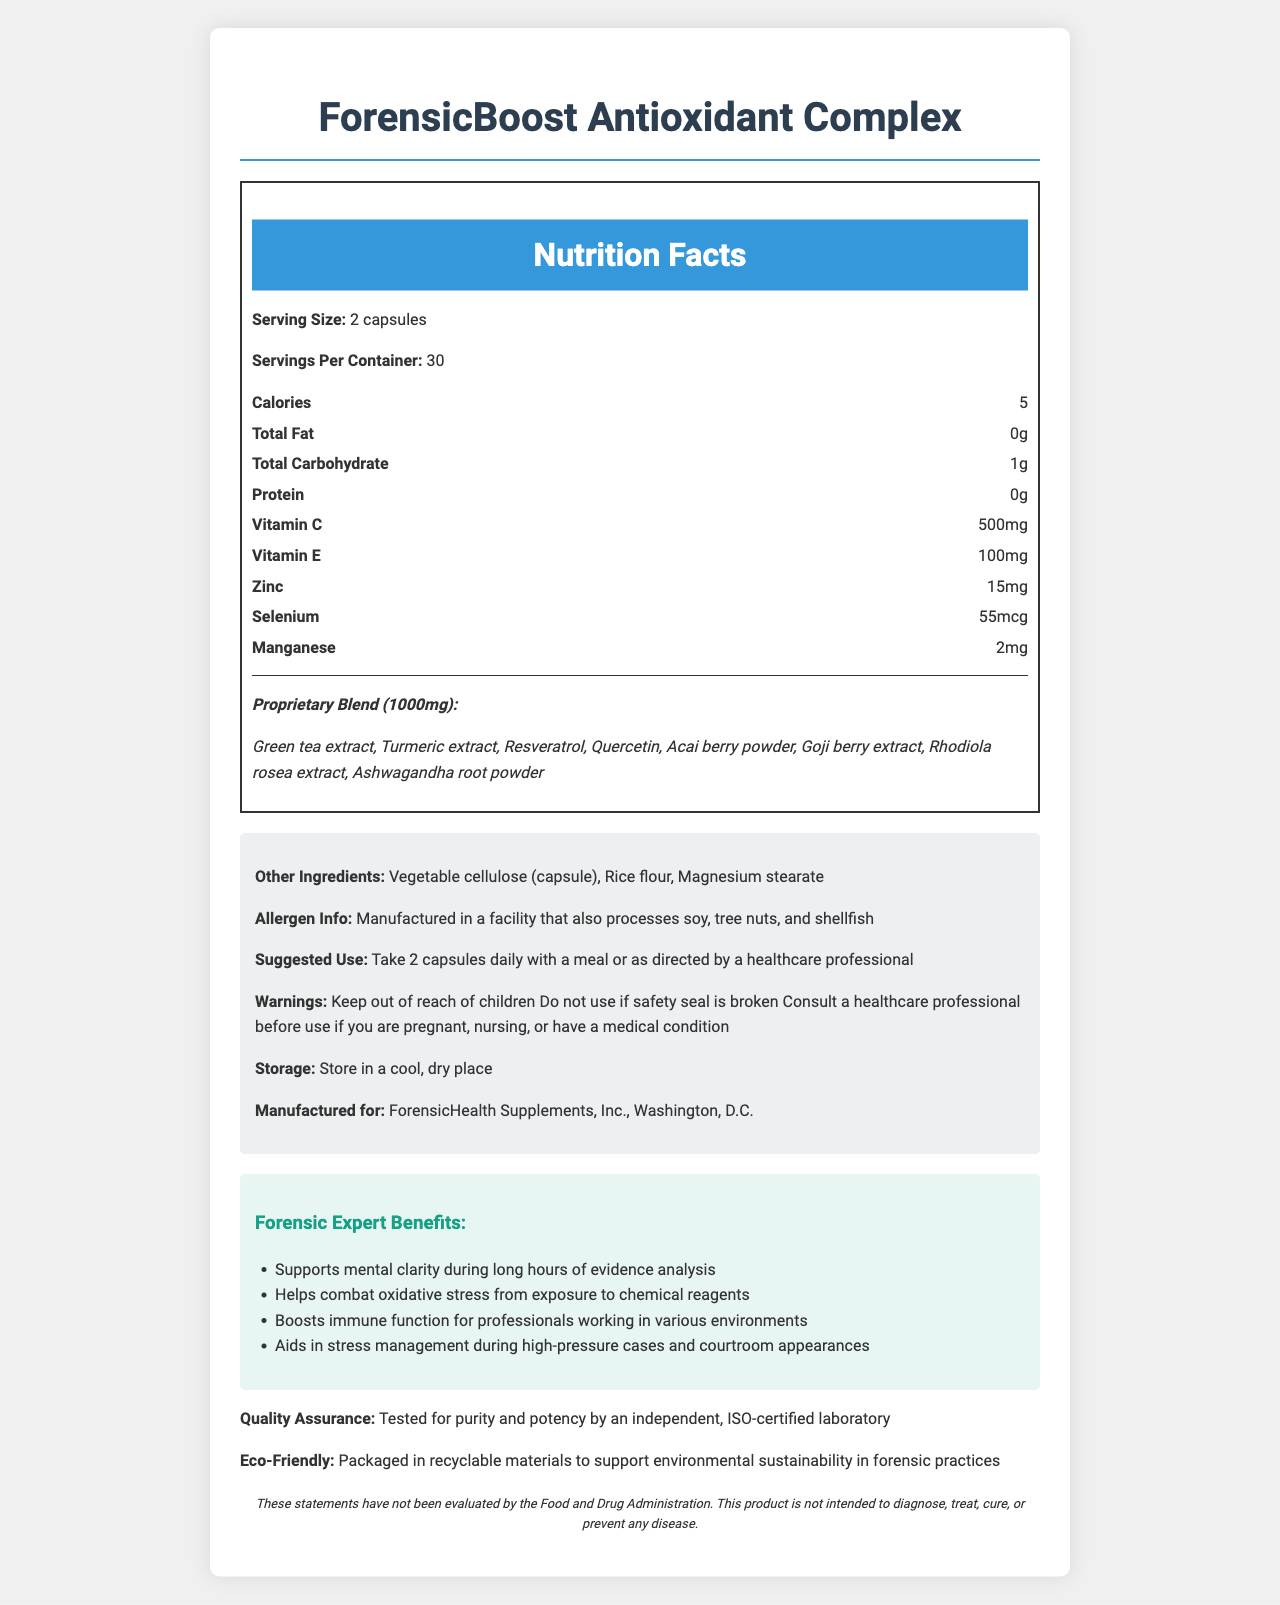what is the serving size of ForensicBoost Antioxidant Complex? The document specifies that the serving size is 2 capsules.
Answer: 2 capsules how many servings are there per container? The document mentions that each container has 30 servings.
Answer: 30 what is the total amount of carbohydrates per serving? According to the nutrition facts, the total carbohydrate per serving is 1 gram.
Answer: 1g which vitamin is present in the highest quantity in each serving? Vitamin C is present in the highest quantity per serving, with 500mg.
Answer: Vitamin C what are the main active ingredients in the proprietary blend? The proprietary blend includes these listed ingredients.
Answer: Green tea extract, Turmeric extract, Resveratrol, Quercetin, Acai berry powder, Goji berry extract, Rhodiola rosea extract, Ashwagandha root powder ForensicBoost Antioxidant Complex provides which mineral that supports immune function? A. Iron B. Zinc C. Magnesium D. Calcium The nutrition facts indicate that each serving contains 15mg of Zinc, which supports immune function.
Answer: B. Zinc How many milligrams of Vitamin E are in each serving? A. 50mg B. 150mg C. 100mg D. 200mg The document lists Vitamin E as 100mg per serving.
Answer: C. 100mg does the product contain any capsules that are non-vegetarian? The capsules are made of vegetable cellulose, which is vegetarian.
Answer: No is the product safe for children to use? The document includes a warning to keep the product out of reach of children.
Answer: No summarize the benefits of ForensicBoost Antioxidant Complex for forensic experts ForensicBoost Antioxidant Complex is tailored to meet the unique needs of forensic experts by enhancing mental clarity, reducing oxidative stress, improving immune function, and managing stress in demanding professional situations.
Answer: Supports mental clarity during long hours of evidence analysis, helps combat oxidative stress, boosts immune function, and aids in stress management during high-pressure cases and courtroom appearances. what is the manufacturing location of ForensicBoost Antioxidant Complex? The document specifies that it is manufactured for ForensicHealth Supplements, Inc., Washington, D.C.
Answer: Washington, D.C. how should the ForensicBoost Antioxidant Complex be stored? The storage instructions advise that the product should be stored in a cool, dry place.
Answer: Store in a cool, dry place does the product contain any allergens? The allergen information indicates potential contact with soy, tree nuts, and shellfish.
Answer: Manufactured in a facility that also processes soy, tree nuts, and shellfish is the efficacy of ForensicBoost Antioxidant Complex scientifically proven? The document states that the claims have not been evaluated by the FDA, implying that efficacy isn't scientifically proven based on the information provided.
Answer: Not enough information identify the eco-friendly aspect of the product packaging The document notes that the product is packaged in recyclable materials to support environmental sustainability.
Answer: Packaged in recyclable materials how often should you take ForensicBoost Antioxidant Complex? The suggested use advises taking 2 capsules daily with a meal or as directed by a healthcare professional.
Answer: Take 2 capsules daily with a meal or as directed by a healthcare professional 